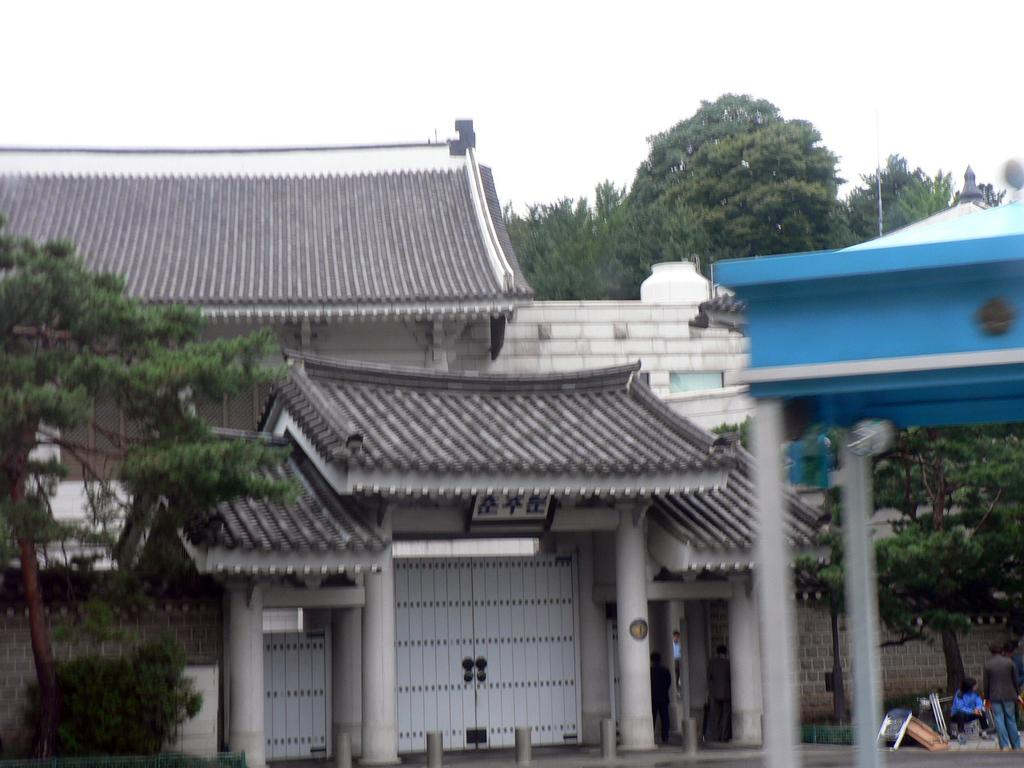What is the main subject of the image? There is a person standing in the image. Where is the person standing in relation to the image? The person is standing toward the right side. What type of natural elements can be seen in the image? There are trees in the image. What type of man-made structure is present in the image? There is a building in the image. What part of the sky is visible in the image? The sky is visible in the image. What type of whip is being used by the person in the image? There is no whip present in the image; the person is simply standing. What answer is the person giving in the image? The image does not depict a conversation or any indication of the person answering a question. 